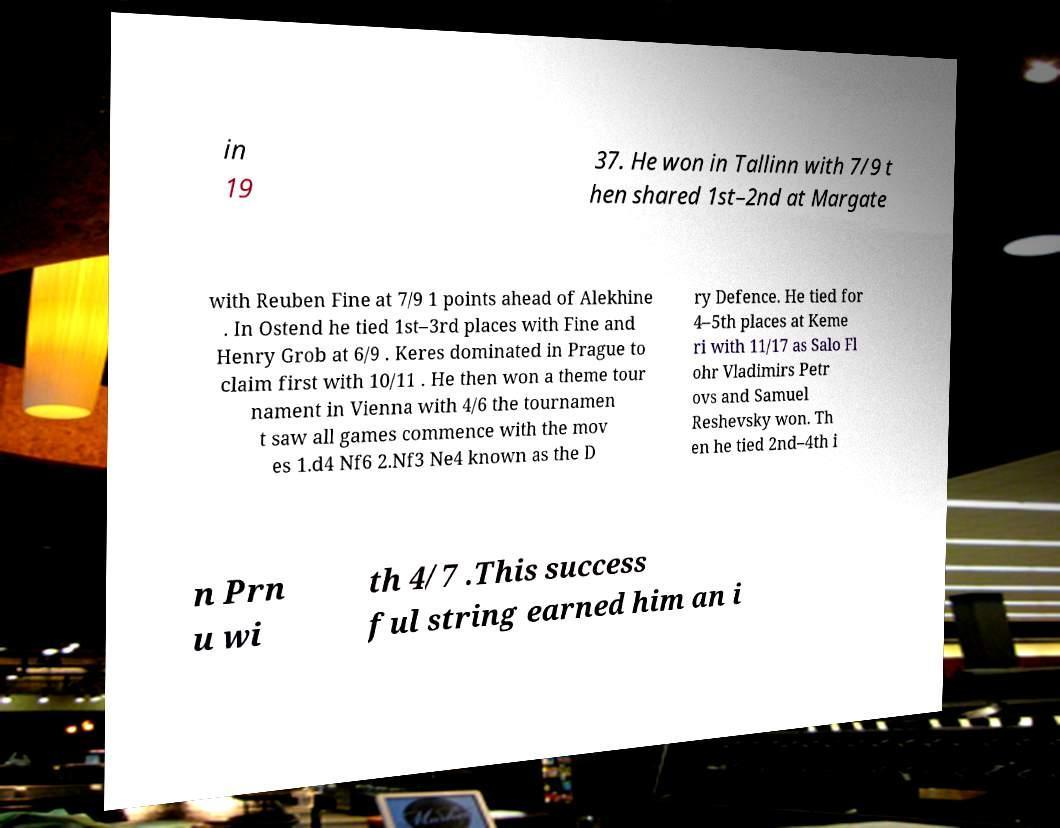Can you accurately transcribe the text from the provided image for me? in 19 37. He won in Tallinn with 7/9 t hen shared 1st–2nd at Margate with Reuben Fine at 7/9 1 points ahead of Alekhine . In Ostend he tied 1st–3rd places with Fine and Henry Grob at 6/9 . Keres dominated in Prague to claim first with 10/11 . He then won a theme tour nament in Vienna with 4/6 the tournamen t saw all games commence with the mov es 1.d4 Nf6 2.Nf3 Ne4 known as the D ry Defence. He tied for 4–5th places at Keme ri with 11/17 as Salo Fl ohr Vladimirs Petr ovs and Samuel Reshevsky won. Th en he tied 2nd–4th i n Prn u wi th 4/7 .This success ful string earned him an i 